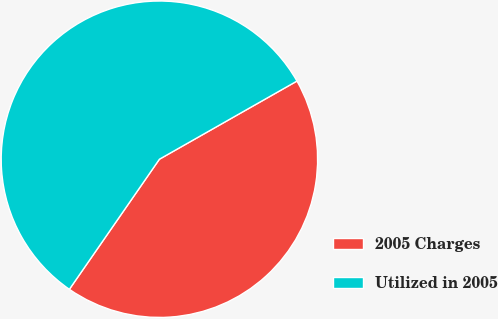Convert chart. <chart><loc_0><loc_0><loc_500><loc_500><pie_chart><fcel>2005 Charges<fcel>Utilized in 2005<nl><fcel>42.86%<fcel>57.14%<nl></chart> 